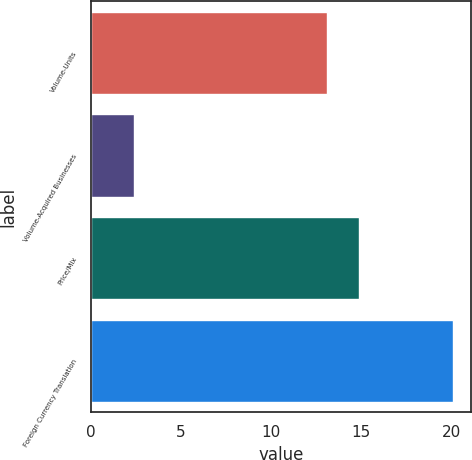<chart> <loc_0><loc_0><loc_500><loc_500><bar_chart><fcel>Volume-Units<fcel>Volume-Acquired Businesses<fcel>Price/Mix<fcel>Foreign Currency Translation<nl><fcel>13.1<fcel>2.4<fcel>14.87<fcel>20.1<nl></chart> 